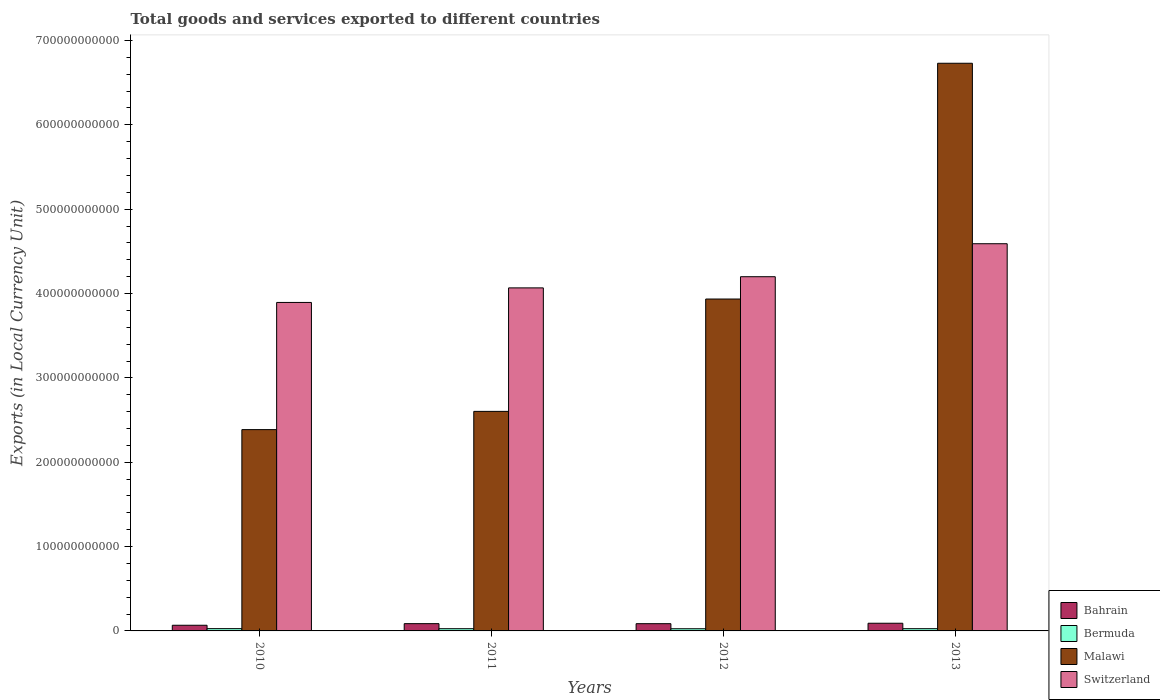How many groups of bars are there?
Give a very brief answer. 4. Are the number of bars on each tick of the X-axis equal?
Provide a short and direct response. Yes. How many bars are there on the 1st tick from the left?
Offer a very short reply. 4. In how many cases, is the number of bars for a given year not equal to the number of legend labels?
Offer a terse response. 0. What is the Amount of goods and services exports in Bermuda in 2011?
Keep it short and to the point. 2.64e+09. Across all years, what is the maximum Amount of goods and services exports in Malawi?
Ensure brevity in your answer.  6.73e+11. Across all years, what is the minimum Amount of goods and services exports in Malawi?
Your answer should be compact. 2.39e+11. What is the total Amount of goods and services exports in Malawi in the graph?
Your answer should be very brief. 1.57e+12. What is the difference between the Amount of goods and services exports in Malawi in 2011 and that in 2012?
Keep it short and to the point. -1.33e+11. What is the difference between the Amount of goods and services exports in Bermuda in 2010 and the Amount of goods and services exports in Switzerland in 2013?
Ensure brevity in your answer.  -4.56e+11. What is the average Amount of goods and services exports in Bahrain per year?
Give a very brief answer. 8.26e+09. In the year 2012, what is the difference between the Amount of goods and services exports in Malawi and Amount of goods and services exports in Switzerland?
Make the answer very short. -2.64e+1. What is the ratio of the Amount of goods and services exports in Malawi in 2010 to that in 2012?
Provide a succinct answer. 0.61. Is the difference between the Amount of goods and services exports in Malawi in 2011 and 2013 greater than the difference between the Amount of goods and services exports in Switzerland in 2011 and 2013?
Offer a very short reply. No. What is the difference between the highest and the second highest Amount of goods and services exports in Malawi?
Keep it short and to the point. 2.80e+11. What is the difference between the highest and the lowest Amount of goods and services exports in Switzerland?
Your response must be concise. 6.96e+1. In how many years, is the Amount of goods and services exports in Switzerland greater than the average Amount of goods and services exports in Switzerland taken over all years?
Offer a terse response. 2. What does the 1st bar from the left in 2010 represents?
Give a very brief answer. Bahrain. What does the 2nd bar from the right in 2013 represents?
Keep it short and to the point. Malawi. Is it the case that in every year, the sum of the Amount of goods and services exports in Bahrain and Amount of goods and services exports in Malawi is greater than the Amount of goods and services exports in Switzerland?
Provide a short and direct response. No. How many years are there in the graph?
Give a very brief answer. 4. What is the difference between two consecutive major ticks on the Y-axis?
Your answer should be very brief. 1.00e+11. Are the values on the major ticks of Y-axis written in scientific E-notation?
Give a very brief answer. No. Does the graph contain any zero values?
Your response must be concise. No. Does the graph contain grids?
Offer a terse response. No. Where does the legend appear in the graph?
Offer a very short reply. Bottom right. What is the title of the graph?
Make the answer very short. Total goods and services exported to different countries. What is the label or title of the X-axis?
Offer a terse response. Years. What is the label or title of the Y-axis?
Provide a short and direct response. Exports (in Local Currency Unit). What is the Exports (in Local Currency Unit) in Bahrain in 2010?
Your answer should be compact. 6.72e+09. What is the Exports (in Local Currency Unit) in Bermuda in 2010?
Your response must be concise. 2.70e+09. What is the Exports (in Local Currency Unit) of Malawi in 2010?
Your response must be concise. 2.39e+11. What is the Exports (in Local Currency Unit) of Switzerland in 2010?
Keep it short and to the point. 3.89e+11. What is the Exports (in Local Currency Unit) of Bahrain in 2011?
Your response must be concise. 8.63e+09. What is the Exports (in Local Currency Unit) of Bermuda in 2011?
Offer a terse response. 2.64e+09. What is the Exports (in Local Currency Unit) in Malawi in 2011?
Your answer should be very brief. 2.60e+11. What is the Exports (in Local Currency Unit) in Switzerland in 2011?
Offer a terse response. 4.07e+11. What is the Exports (in Local Currency Unit) of Bahrain in 2012?
Offer a terse response. 8.59e+09. What is the Exports (in Local Currency Unit) in Bermuda in 2012?
Provide a short and direct response. 2.59e+09. What is the Exports (in Local Currency Unit) of Malawi in 2012?
Your response must be concise. 3.94e+11. What is the Exports (in Local Currency Unit) in Switzerland in 2012?
Provide a short and direct response. 4.20e+11. What is the Exports (in Local Currency Unit) in Bahrain in 2013?
Provide a succinct answer. 9.11e+09. What is the Exports (in Local Currency Unit) of Bermuda in 2013?
Your answer should be very brief. 2.66e+09. What is the Exports (in Local Currency Unit) of Malawi in 2013?
Make the answer very short. 6.73e+11. What is the Exports (in Local Currency Unit) of Switzerland in 2013?
Provide a short and direct response. 4.59e+11. Across all years, what is the maximum Exports (in Local Currency Unit) in Bahrain?
Give a very brief answer. 9.11e+09. Across all years, what is the maximum Exports (in Local Currency Unit) in Bermuda?
Your answer should be very brief. 2.70e+09. Across all years, what is the maximum Exports (in Local Currency Unit) of Malawi?
Keep it short and to the point. 6.73e+11. Across all years, what is the maximum Exports (in Local Currency Unit) in Switzerland?
Offer a terse response. 4.59e+11. Across all years, what is the minimum Exports (in Local Currency Unit) in Bahrain?
Ensure brevity in your answer.  6.72e+09. Across all years, what is the minimum Exports (in Local Currency Unit) of Bermuda?
Your answer should be very brief. 2.59e+09. Across all years, what is the minimum Exports (in Local Currency Unit) of Malawi?
Provide a short and direct response. 2.39e+11. Across all years, what is the minimum Exports (in Local Currency Unit) of Switzerland?
Ensure brevity in your answer.  3.89e+11. What is the total Exports (in Local Currency Unit) in Bahrain in the graph?
Your answer should be very brief. 3.31e+1. What is the total Exports (in Local Currency Unit) in Bermuda in the graph?
Offer a very short reply. 1.06e+1. What is the total Exports (in Local Currency Unit) in Malawi in the graph?
Keep it short and to the point. 1.57e+12. What is the total Exports (in Local Currency Unit) of Switzerland in the graph?
Provide a succinct answer. 1.68e+12. What is the difference between the Exports (in Local Currency Unit) of Bahrain in 2010 and that in 2011?
Give a very brief answer. -1.90e+09. What is the difference between the Exports (in Local Currency Unit) in Bermuda in 2010 and that in 2011?
Your answer should be very brief. 6.04e+07. What is the difference between the Exports (in Local Currency Unit) of Malawi in 2010 and that in 2011?
Offer a terse response. -2.16e+1. What is the difference between the Exports (in Local Currency Unit) in Switzerland in 2010 and that in 2011?
Your response must be concise. -1.73e+1. What is the difference between the Exports (in Local Currency Unit) of Bahrain in 2010 and that in 2012?
Offer a very short reply. -1.87e+09. What is the difference between the Exports (in Local Currency Unit) of Bermuda in 2010 and that in 2012?
Provide a short and direct response. 1.15e+08. What is the difference between the Exports (in Local Currency Unit) of Malawi in 2010 and that in 2012?
Provide a succinct answer. -1.55e+11. What is the difference between the Exports (in Local Currency Unit) of Switzerland in 2010 and that in 2012?
Provide a succinct answer. -3.05e+1. What is the difference between the Exports (in Local Currency Unit) of Bahrain in 2010 and that in 2013?
Give a very brief answer. -2.39e+09. What is the difference between the Exports (in Local Currency Unit) of Bermuda in 2010 and that in 2013?
Keep it short and to the point. 4.78e+07. What is the difference between the Exports (in Local Currency Unit) of Malawi in 2010 and that in 2013?
Your answer should be compact. -4.34e+11. What is the difference between the Exports (in Local Currency Unit) of Switzerland in 2010 and that in 2013?
Your response must be concise. -6.96e+1. What is the difference between the Exports (in Local Currency Unit) of Bahrain in 2011 and that in 2012?
Make the answer very short. 3.47e+07. What is the difference between the Exports (in Local Currency Unit) in Bermuda in 2011 and that in 2012?
Your response must be concise. 5.48e+07. What is the difference between the Exports (in Local Currency Unit) of Malawi in 2011 and that in 2012?
Your response must be concise. -1.33e+11. What is the difference between the Exports (in Local Currency Unit) of Switzerland in 2011 and that in 2012?
Offer a terse response. -1.32e+1. What is the difference between the Exports (in Local Currency Unit) in Bahrain in 2011 and that in 2013?
Offer a very short reply. -4.82e+08. What is the difference between the Exports (in Local Currency Unit) in Bermuda in 2011 and that in 2013?
Provide a short and direct response. -1.27e+07. What is the difference between the Exports (in Local Currency Unit) of Malawi in 2011 and that in 2013?
Provide a short and direct response. -4.13e+11. What is the difference between the Exports (in Local Currency Unit) of Switzerland in 2011 and that in 2013?
Your answer should be compact. -5.24e+1. What is the difference between the Exports (in Local Currency Unit) of Bahrain in 2012 and that in 2013?
Your answer should be very brief. -5.17e+08. What is the difference between the Exports (in Local Currency Unit) of Bermuda in 2012 and that in 2013?
Provide a succinct answer. -6.75e+07. What is the difference between the Exports (in Local Currency Unit) in Malawi in 2012 and that in 2013?
Give a very brief answer. -2.80e+11. What is the difference between the Exports (in Local Currency Unit) in Switzerland in 2012 and that in 2013?
Keep it short and to the point. -3.91e+1. What is the difference between the Exports (in Local Currency Unit) of Bahrain in 2010 and the Exports (in Local Currency Unit) of Bermuda in 2011?
Your answer should be compact. 4.08e+09. What is the difference between the Exports (in Local Currency Unit) of Bahrain in 2010 and the Exports (in Local Currency Unit) of Malawi in 2011?
Make the answer very short. -2.54e+11. What is the difference between the Exports (in Local Currency Unit) in Bahrain in 2010 and the Exports (in Local Currency Unit) in Switzerland in 2011?
Make the answer very short. -4.00e+11. What is the difference between the Exports (in Local Currency Unit) in Bermuda in 2010 and the Exports (in Local Currency Unit) in Malawi in 2011?
Provide a succinct answer. -2.58e+11. What is the difference between the Exports (in Local Currency Unit) of Bermuda in 2010 and the Exports (in Local Currency Unit) of Switzerland in 2011?
Keep it short and to the point. -4.04e+11. What is the difference between the Exports (in Local Currency Unit) of Malawi in 2010 and the Exports (in Local Currency Unit) of Switzerland in 2011?
Give a very brief answer. -1.68e+11. What is the difference between the Exports (in Local Currency Unit) of Bahrain in 2010 and the Exports (in Local Currency Unit) of Bermuda in 2012?
Your response must be concise. 4.13e+09. What is the difference between the Exports (in Local Currency Unit) in Bahrain in 2010 and the Exports (in Local Currency Unit) in Malawi in 2012?
Keep it short and to the point. -3.87e+11. What is the difference between the Exports (in Local Currency Unit) in Bahrain in 2010 and the Exports (in Local Currency Unit) in Switzerland in 2012?
Keep it short and to the point. -4.13e+11. What is the difference between the Exports (in Local Currency Unit) of Bermuda in 2010 and the Exports (in Local Currency Unit) of Malawi in 2012?
Give a very brief answer. -3.91e+11. What is the difference between the Exports (in Local Currency Unit) of Bermuda in 2010 and the Exports (in Local Currency Unit) of Switzerland in 2012?
Keep it short and to the point. -4.17e+11. What is the difference between the Exports (in Local Currency Unit) of Malawi in 2010 and the Exports (in Local Currency Unit) of Switzerland in 2012?
Make the answer very short. -1.81e+11. What is the difference between the Exports (in Local Currency Unit) in Bahrain in 2010 and the Exports (in Local Currency Unit) in Bermuda in 2013?
Your answer should be very brief. 4.07e+09. What is the difference between the Exports (in Local Currency Unit) in Bahrain in 2010 and the Exports (in Local Currency Unit) in Malawi in 2013?
Ensure brevity in your answer.  -6.66e+11. What is the difference between the Exports (in Local Currency Unit) in Bahrain in 2010 and the Exports (in Local Currency Unit) in Switzerland in 2013?
Provide a succinct answer. -4.52e+11. What is the difference between the Exports (in Local Currency Unit) in Bermuda in 2010 and the Exports (in Local Currency Unit) in Malawi in 2013?
Offer a terse response. -6.70e+11. What is the difference between the Exports (in Local Currency Unit) in Bermuda in 2010 and the Exports (in Local Currency Unit) in Switzerland in 2013?
Offer a very short reply. -4.56e+11. What is the difference between the Exports (in Local Currency Unit) in Malawi in 2010 and the Exports (in Local Currency Unit) in Switzerland in 2013?
Your response must be concise. -2.20e+11. What is the difference between the Exports (in Local Currency Unit) in Bahrain in 2011 and the Exports (in Local Currency Unit) in Bermuda in 2012?
Your response must be concise. 6.04e+09. What is the difference between the Exports (in Local Currency Unit) of Bahrain in 2011 and the Exports (in Local Currency Unit) of Malawi in 2012?
Provide a short and direct response. -3.85e+11. What is the difference between the Exports (in Local Currency Unit) of Bahrain in 2011 and the Exports (in Local Currency Unit) of Switzerland in 2012?
Give a very brief answer. -4.11e+11. What is the difference between the Exports (in Local Currency Unit) of Bermuda in 2011 and the Exports (in Local Currency Unit) of Malawi in 2012?
Make the answer very short. -3.91e+11. What is the difference between the Exports (in Local Currency Unit) in Bermuda in 2011 and the Exports (in Local Currency Unit) in Switzerland in 2012?
Offer a terse response. -4.17e+11. What is the difference between the Exports (in Local Currency Unit) in Malawi in 2011 and the Exports (in Local Currency Unit) in Switzerland in 2012?
Make the answer very short. -1.60e+11. What is the difference between the Exports (in Local Currency Unit) of Bahrain in 2011 and the Exports (in Local Currency Unit) of Bermuda in 2013?
Your response must be concise. 5.97e+09. What is the difference between the Exports (in Local Currency Unit) in Bahrain in 2011 and the Exports (in Local Currency Unit) in Malawi in 2013?
Keep it short and to the point. -6.64e+11. What is the difference between the Exports (in Local Currency Unit) of Bahrain in 2011 and the Exports (in Local Currency Unit) of Switzerland in 2013?
Your answer should be very brief. -4.50e+11. What is the difference between the Exports (in Local Currency Unit) in Bermuda in 2011 and the Exports (in Local Currency Unit) in Malawi in 2013?
Your answer should be very brief. -6.70e+11. What is the difference between the Exports (in Local Currency Unit) of Bermuda in 2011 and the Exports (in Local Currency Unit) of Switzerland in 2013?
Keep it short and to the point. -4.56e+11. What is the difference between the Exports (in Local Currency Unit) of Malawi in 2011 and the Exports (in Local Currency Unit) of Switzerland in 2013?
Offer a very short reply. -1.99e+11. What is the difference between the Exports (in Local Currency Unit) in Bahrain in 2012 and the Exports (in Local Currency Unit) in Bermuda in 2013?
Make the answer very short. 5.94e+09. What is the difference between the Exports (in Local Currency Unit) in Bahrain in 2012 and the Exports (in Local Currency Unit) in Malawi in 2013?
Ensure brevity in your answer.  -6.64e+11. What is the difference between the Exports (in Local Currency Unit) of Bahrain in 2012 and the Exports (in Local Currency Unit) of Switzerland in 2013?
Provide a short and direct response. -4.50e+11. What is the difference between the Exports (in Local Currency Unit) of Bermuda in 2012 and the Exports (in Local Currency Unit) of Malawi in 2013?
Provide a short and direct response. -6.70e+11. What is the difference between the Exports (in Local Currency Unit) in Bermuda in 2012 and the Exports (in Local Currency Unit) in Switzerland in 2013?
Your response must be concise. -4.56e+11. What is the difference between the Exports (in Local Currency Unit) of Malawi in 2012 and the Exports (in Local Currency Unit) of Switzerland in 2013?
Provide a short and direct response. -6.56e+1. What is the average Exports (in Local Currency Unit) of Bahrain per year?
Offer a terse response. 8.26e+09. What is the average Exports (in Local Currency Unit) of Bermuda per year?
Your answer should be compact. 2.65e+09. What is the average Exports (in Local Currency Unit) in Malawi per year?
Your answer should be compact. 3.91e+11. What is the average Exports (in Local Currency Unit) in Switzerland per year?
Your answer should be very brief. 4.19e+11. In the year 2010, what is the difference between the Exports (in Local Currency Unit) of Bahrain and Exports (in Local Currency Unit) of Bermuda?
Offer a very short reply. 4.02e+09. In the year 2010, what is the difference between the Exports (in Local Currency Unit) of Bahrain and Exports (in Local Currency Unit) of Malawi?
Offer a very short reply. -2.32e+11. In the year 2010, what is the difference between the Exports (in Local Currency Unit) in Bahrain and Exports (in Local Currency Unit) in Switzerland?
Keep it short and to the point. -3.83e+11. In the year 2010, what is the difference between the Exports (in Local Currency Unit) in Bermuda and Exports (in Local Currency Unit) in Malawi?
Give a very brief answer. -2.36e+11. In the year 2010, what is the difference between the Exports (in Local Currency Unit) of Bermuda and Exports (in Local Currency Unit) of Switzerland?
Your answer should be very brief. -3.87e+11. In the year 2010, what is the difference between the Exports (in Local Currency Unit) in Malawi and Exports (in Local Currency Unit) in Switzerland?
Provide a short and direct response. -1.51e+11. In the year 2011, what is the difference between the Exports (in Local Currency Unit) of Bahrain and Exports (in Local Currency Unit) of Bermuda?
Provide a short and direct response. 5.98e+09. In the year 2011, what is the difference between the Exports (in Local Currency Unit) of Bahrain and Exports (in Local Currency Unit) of Malawi?
Your answer should be very brief. -2.52e+11. In the year 2011, what is the difference between the Exports (in Local Currency Unit) of Bahrain and Exports (in Local Currency Unit) of Switzerland?
Provide a short and direct response. -3.98e+11. In the year 2011, what is the difference between the Exports (in Local Currency Unit) of Bermuda and Exports (in Local Currency Unit) of Malawi?
Provide a short and direct response. -2.58e+11. In the year 2011, what is the difference between the Exports (in Local Currency Unit) of Bermuda and Exports (in Local Currency Unit) of Switzerland?
Your answer should be very brief. -4.04e+11. In the year 2011, what is the difference between the Exports (in Local Currency Unit) of Malawi and Exports (in Local Currency Unit) of Switzerland?
Keep it short and to the point. -1.46e+11. In the year 2012, what is the difference between the Exports (in Local Currency Unit) of Bahrain and Exports (in Local Currency Unit) of Bermuda?
Your response must be concise. 6.00e+09. In the year 2012, what is the difference between the Exports (in Local Currency Unit) in Bahrain and Exports (in Local Currency Unit) in Malawi?
Make the answer very short. -3.85e+11. In the year 2012, what is the difference between the Exports (in Local Currency Unit) of Bahrain and Exports (in Local Currency Unit) of Switzerland?
Provide a short and direct response. -4.11e+11. In the year 2012, what is the difference between the Exports (in Local Currency Unit) of Bermuda and Exports (in Local Currency Unit) of Malawi?
Provide a succinct answer. -3.91e+11. In the year 2012, what is the difference between the Exports (in Local Currency Unit) in Bermuda and Exports (in Local Currency Unit) in Switzerland?
Your answer should be very brief. -4.17e+11. In the year 2012, what is the difference between the Exports (in Local Currency Unit) in Malawi and Exports (in Local Currency Unit) in Switzerland?
Make the answer very short. -2.64e+1. In the year 2013, what is the difference between the Exports (in Local Currency Unit) of Bahrain and Exports (in Local Currency Unit) of Bermuda?
Your answer should be very brief. 6.45e+09. In the year 2013, what is the difference between the Exports (in Local Currency Unit) in Bahrain and Exports (in Local Currency Unit) in Malawi?
Your answer should be very brief. -6.64e+11. In the year 2013, what is the difference between the Exports (in Local Currency Unit) in Bahrain and Exports (in Local Currency Unit) in Switzerland?
Your response must be concise. -4.50e+11. In the year 2013, what is the difference between the Exports (in Local Currency Unit) in Bermuda and Exports (in Local Currency Unit) in Malawi?
Make the answer very short. -6.70e+11. In the year 2013, what is the difference between the Exports (in Local Currency Unit) of Bermuda and Exports (in Local Currency Unit) of Switzerland?
Ensure brevity in your answer.  -4.56e+11. In the year 2013, what is the difference between the Exports (in Local Currency Unit) of Malawi and Exports (in Local Currency Unit) of Switzerland?
Provide a succinct answer. 2.14e+11. What is the ratio of the Exports (in Local Currency Unit) in Bahrain in 2010 to that in 2011?
Your answer should be very brief. 0.78. What is the ratio of the Exports (in Local Currency Unit) of Bermuda in 2010 to that in 2011?
Your answer should be very brief. 1.02. What is the ratio of the Exports (in Local Currency Unit) of Malawi in 2010 to that in 2011?
Keep it short and to the point. 0.92. What is the ratio of the Exports (in Local Currency Unit) of Switzerland in 2010 to that in 2011?
Offer a terse response. 0.96. What is the ratio of the Exports (in Local Currency Unit) in Bahrain in 2010 to that in 2012?
Provide a succinct answer. 0.78. What is the ratio of the Exports (in Local Currency Unit) in Bermuda in 2010 to that in 2012?
Provide a succinct answer. 1.04. What is the ratio of the Exports (in Local Currency Unit) in Malawi in 2010 to that in 2012?
Give a very brief answer. 0.61. What is the ratio of the Exports (in Local Currency Unit) in Switzerland in 2010 to that in 2012?
Your answer should be very brief. 0.93. What is the ratio of the Exports (in Local Currency Unit) in Bahrain in 2010 to that in 2013?
Give a very brief answer. 0.74. What is the ratio of the Exports (in Local Currency Unit) of Bermuda in 2010 to that in 2013?
Offer a very short reply. 1.02. What is the ratio of the Exports (in Local Currency Unit) in Malawi in 2010 to that in 2013?
Your answer should be very brief. 0.35. What is the ratio of the Exports (in Local Currency Unit) of Switzerland in 2010 to that in 2013?
Your answer should be compact. 0.85. What is the ratio of the Exports (in Local Currency Unit) in Bermuda in 2011 to that in 2012?
Make the answer very short. 1.02. What is the ratio of the Exports (in Local Currency Unit) in Malawi in 2011 to that in 2012?
Offer a very short reply. 0.66. What is the ratio of the Exports (in Local Currency Unit) in Switzerland in 2011 to that in 2012?
Your answer should be very brief. 0.97. What is the ratio of the Exports (in Local Currency Unit) of Bahrain in 2011 to that in 2013?
Provide a short and direct response. 0.95. What is the ratio of the Exports (in Local Currency Unit) in Malawi in 2011 to that in 2013?
Your response must be concise. 0.39. What is the ratio of the Exports (in Local Currency Unit) of Switzerland in 2011 to that in 2013?
Give a very brief answer. 0.89. What is the ratio of the Exports (in Local Currency Unit) of Bahrain in 2012 to that in 2013?
Offer a very short reply. 0.94. What is the ratio of the Exports (in Local Currency Unit) in Bermuda in 2012 to that in 2013?
Offer a very short reply. 0.97. What is the ratio of the Exports (in Local Currency Unit) in Malawi in 2012 to that in 2013?
Provide a short and direct response. 0.58. What is the ratio of the Exports (in Local Currency Unit) in Switzerland in 2012 to that in 2013?
Provide a short and direct response. 0.91. What is the difference between the highest and the second highest Exports (in Local Currency Unit) of Bahrain?
Offer a terse response. 4.82e+08. What is the difference between the highest and the second highest Exports (in Local Currency Unit) in Bermuda?
Give a very brief answer. 4.78e+07. What is the difference between the highest and the second highest Exports (in Local Currency Unit) of Malawi?
Give a very brief answer. 2.80e+11. What is the difference between the highest and the second highest Exports (in Local Currency Unit) in Switzerland?
Provide a succinct answer. 3.91e+1. What is the difference between the highest and the lowest Exports (in Local Currency Unit) of Bahrain?
Give a very brief answer. 2.39e+09. What is the difference between the highest and the lowest Exports (in Local Currency Unit) of Bermuda?
Your response must be concise. 1.15e+08. What is the difference between the highest and the lowest Exports (in Local Currency Unit) in Malawi?
Ensure brevity in your answer.  4.34e+11. What is the difference between the highest and the lowest Exports (in Local Currency Unit) in Switzerland?
Ensure brevity in your answer.  6.96e+1. 